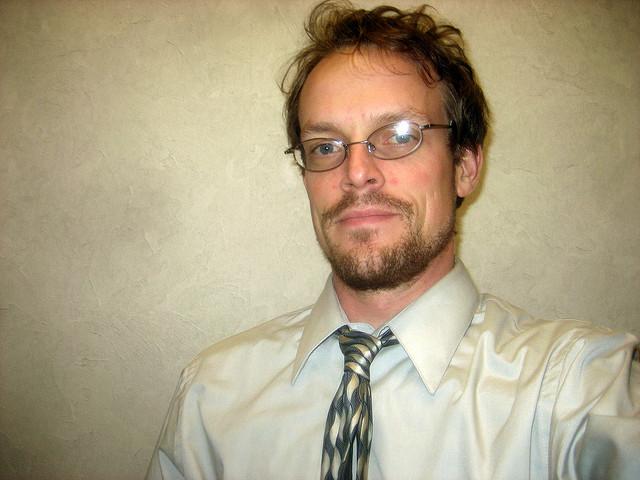What color is his shirt?
Concise answer only. White. What is on the man's face?
Give a very brief answer. Glasses. Does this person present a well-pressed magazine-cover-ready appearance?
Keep it brief. No. Is this person's tie loose?
Quick response, please. No. What is on the man's head?
Answer briefly. Hair. 